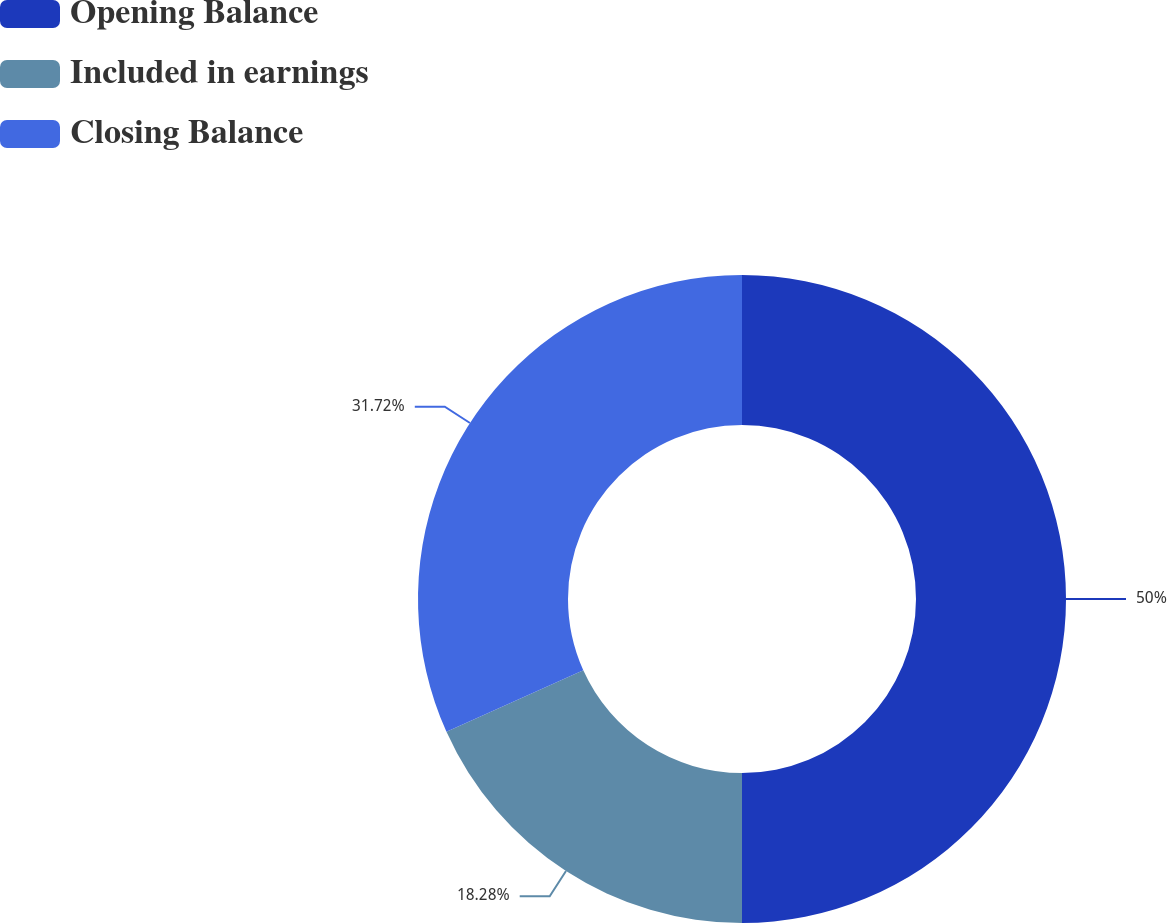Convert chart to OTSL. <chart><loc_0><loc_0><loc_500><loc_500><pie_chart><fcel>Opening Balance<fcel>Included in earnings<fcel>Closing Balance<nl><fcel>50.0%<fcel>18.28%<fcel>31.72%<nl></chart> 